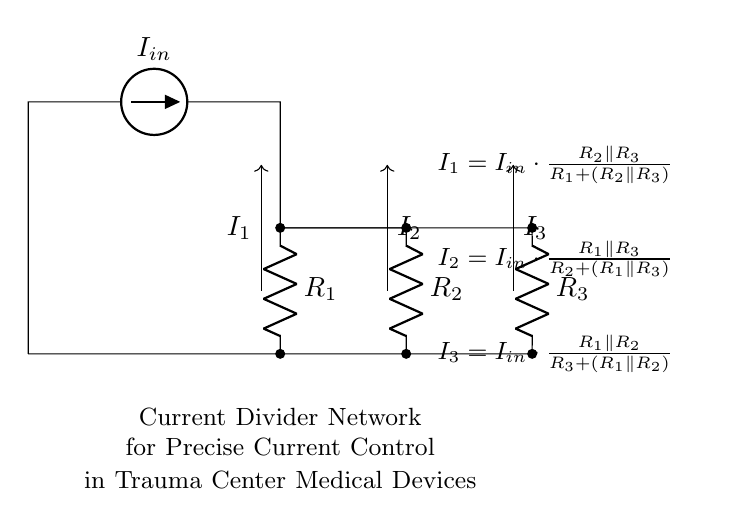What is the current source value in the circuit? The circuit shows an American current source labeled as \( I_{in} \). The value of this current source is not specified in the diagram, but it is the input current into the divider network.
Answer: I_{in} How many resistors are present in the circuit? The circuit diagram displays three resistors: \( R_1 \), \( R_2 \), and \( R_3 \). These resistors are connected in a current divider configuration.
Answer: 3 What is the formula for \( I_1 \)? The formula for \( I_1 \) is provided in the circuit as \( I_1 = I_{in} \cdot \frac{R_2 \parallel R_3}{R_1 + (R_2 \parallel R_3)} \). This equation relates the input current to \( I_1 \) based on the resistor values.
Answer: I_1 = I_{in} \cdot \frac{R_2 \parallel R_3}{R_1 + (R_2 \parallel R_3)} Which resistors are involved in calculating \( I_3 \)? The formula for \( I_3 \) indicates the use of \( R_1 \) and \( R_2 \) along with \( R_3 \) in its calculation. Specifically, it shows that \( I_3 \) is determined by \( R_1 \) and \( R_2 \) in parallel to \( R_3 \).
Answer: R_1, R_2, R_3 What is the arrangement of the resistors in the current divider? The resistors \( R_2 \) and \( R_3 \) are in parallel, and the combination is in series with \( R_1 \). This configuration defines the current divider setup, which splits the input current into different paths.
Answer: R_1 in series with R_2 and R_3 in parallel How do you calculate the current through \( R_2 \)? To find the current through \( R_2 \) (i.e., \( I_2 \)), you can use the formula given in the circuit: \( I_2 = I_{in} \cdot \frac{R_1 \parallel R_3}{R_2 + (R_1 \parallel R_3)} \). This calculation requires knowing the values of the resistors in the circuit.
Answer: I_2 = I_{in} \cdot \frac{R_1 \parallel R_3}{R_2 + (R_1 \parallel R_3)} 